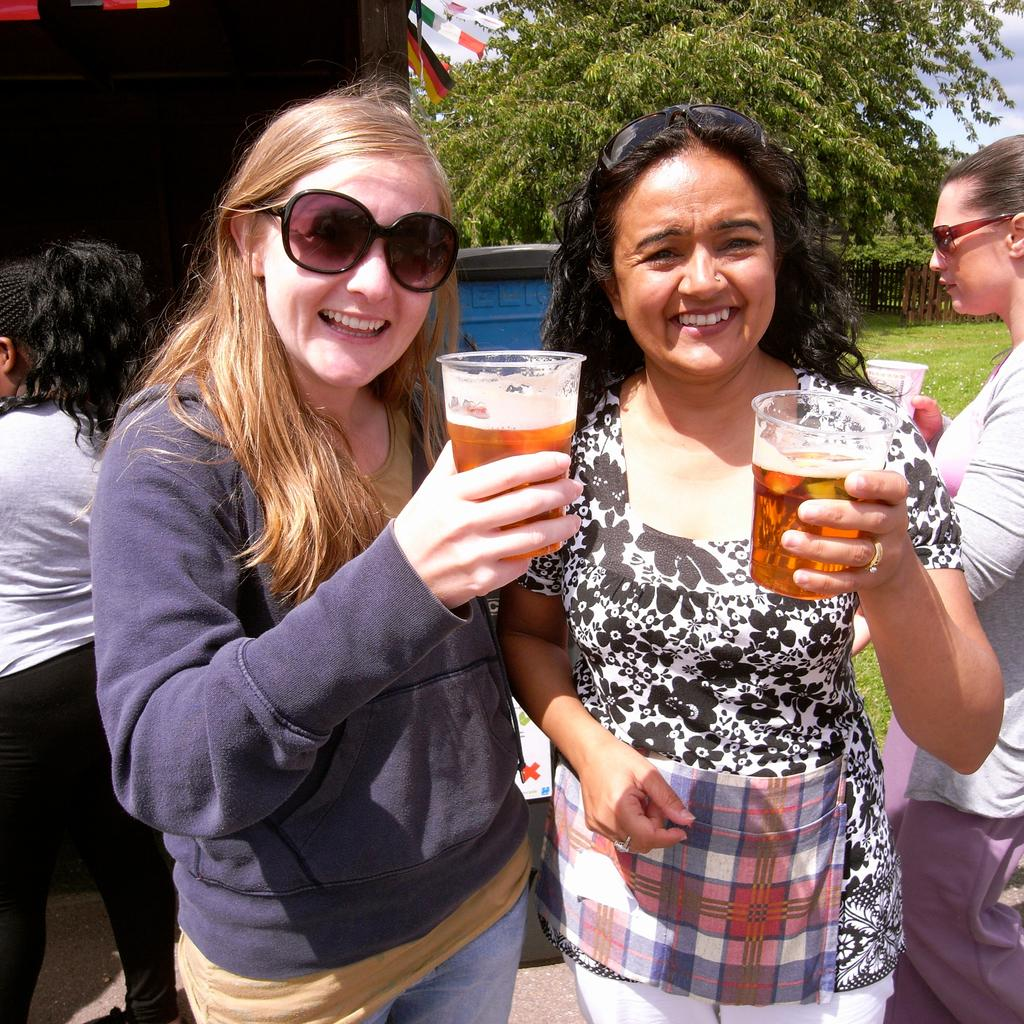Who or what is present in the image? There are people in the image. What are the people doing in the image? The people are standing in the image. What objects are the people holding in their hands? The people are holding wine glasses in their hands. What can be seen in the background of the image? There are trees visible in the background of the image. What type of juice is being served at the birthday celebration in the image? There is no birthday celebration or juice present in the image. The people are holding wine glasses, not juice glasses. 